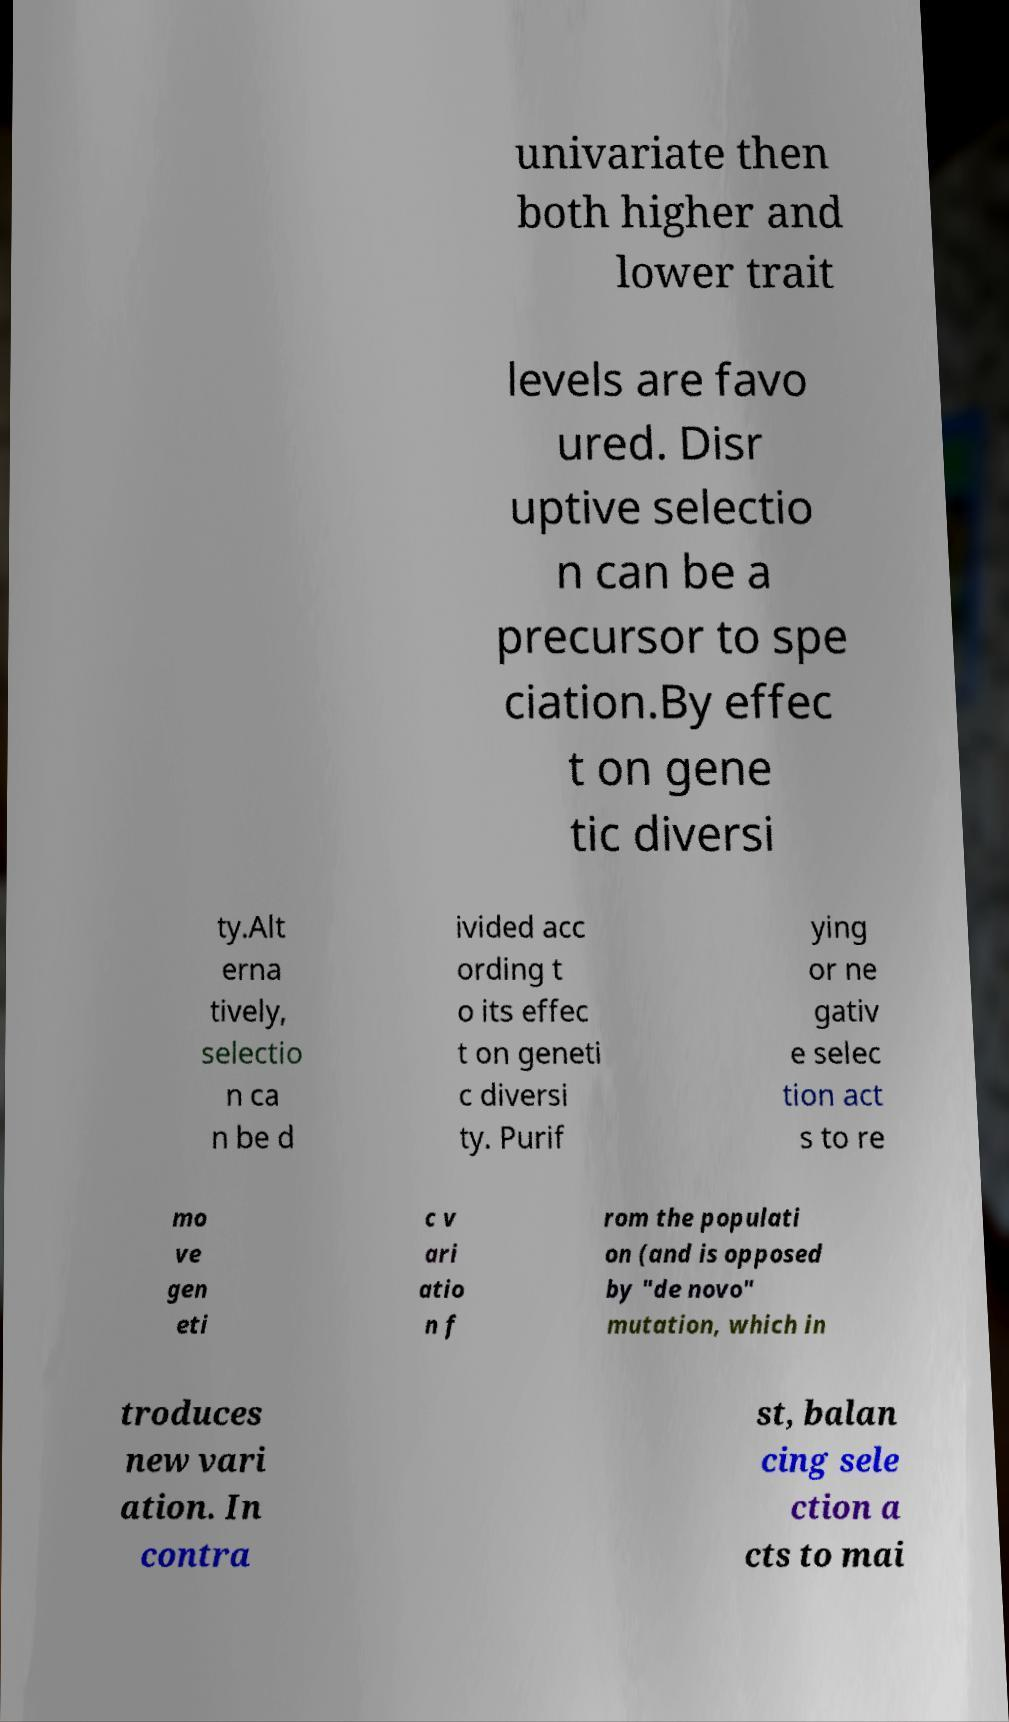Can you read and provide the text displayed in the image?This photo seems to have some interesting text. Can you extract and type it out for me? univariate then both higher and lower trait levels are favo ured. Disr uptive selectio n can be a precursor to spe ciation.By effec t on gene tic diversi ty.Alt erna tively, selectio n ca n be d ivided acc ording t o its effec t on geneti c diversi ty. Purif ying or ne gativ e selec tion act s to re mo ve gen eti c v ari atio n f rom the populati on (and is opposed by "de novo" mutation, which in troduces new vari ation. In contra st, balan cing sele ction a cts to mai 